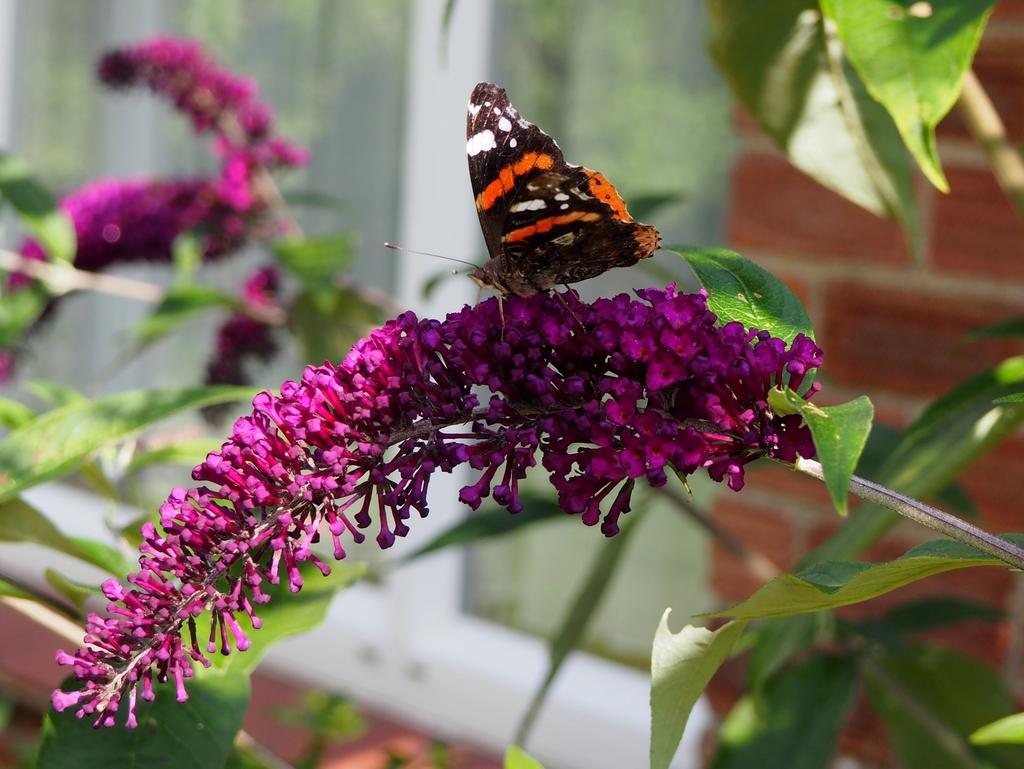Can you describe this image briefly? In this image I can see a butterfly on the flower and the butterfly is in brown and orange color and the flowers are in pink color and I can see leaves in green color. 